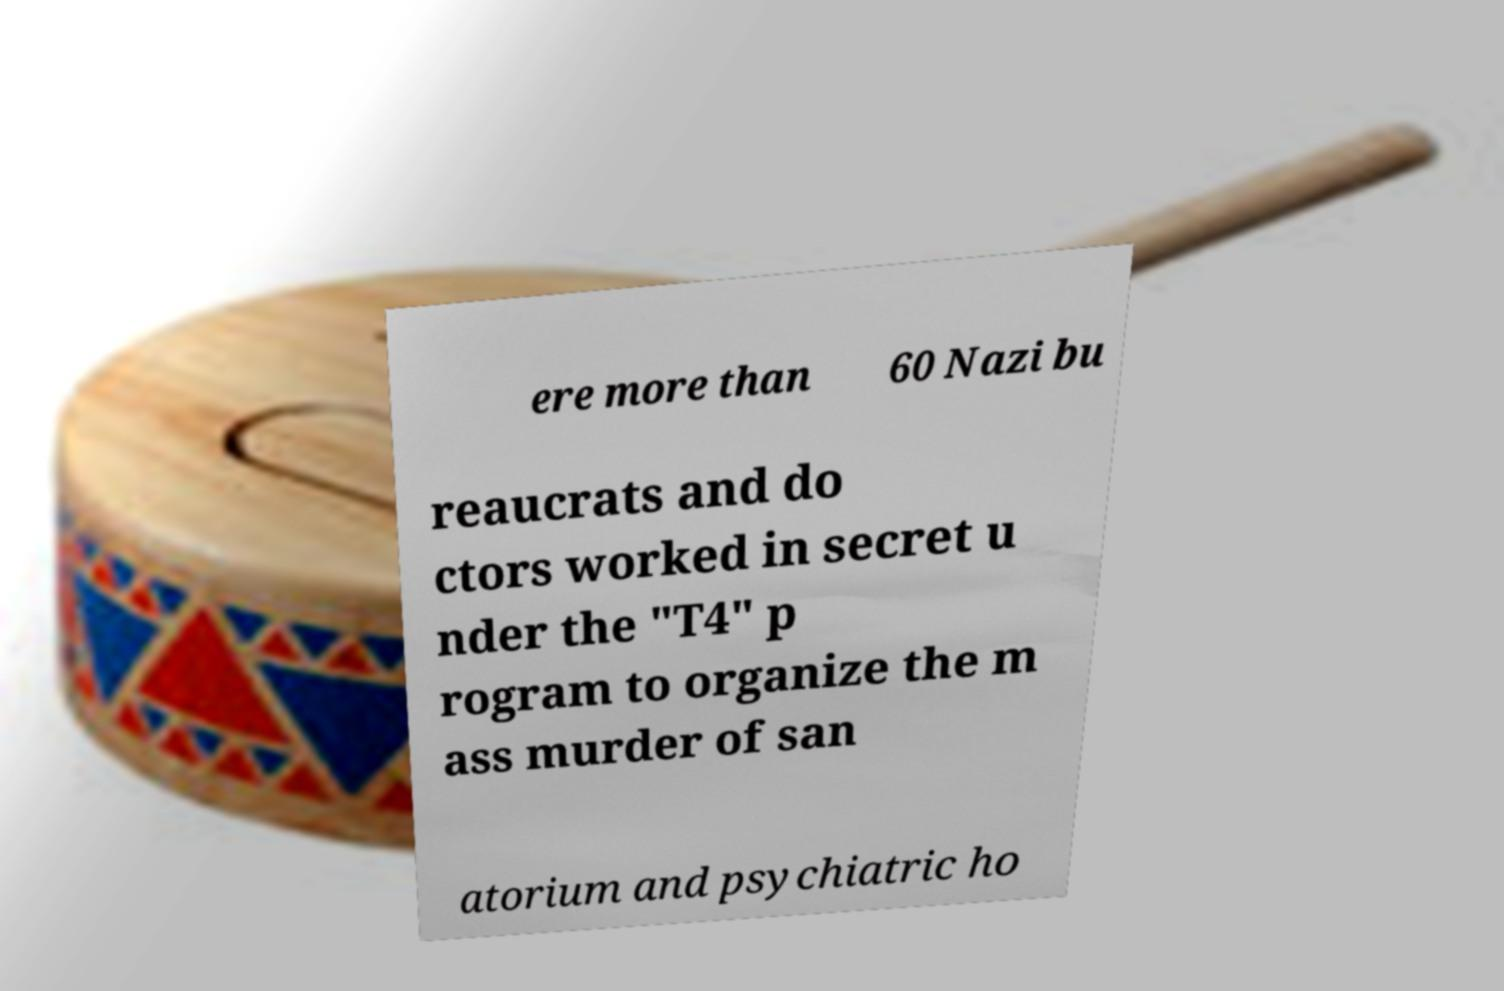Can you read and provide the text displayed in the image?This photo seems to have some interesting text. Can you extract and type it out for me? ere more than 60 Nazi bu reaucrats and do ctors worked in secret u nder the "T4" p rogram to organize the m ass murder of san atorium and psychiatric ho 